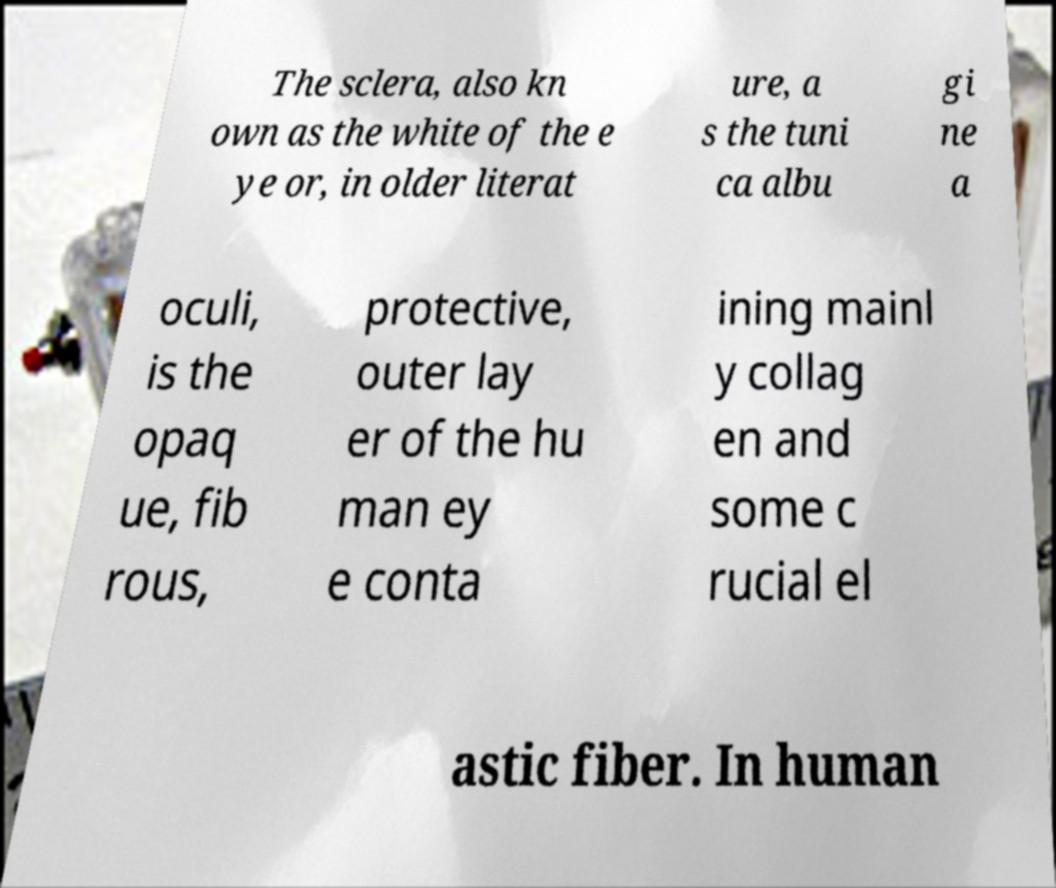Please identify and transcribe the text found in this image. The sclera, also kn own as the white of the e ye or, in older literat ure, a s the tuni ca albu gi ne a oculi, is the opaq ue, fib rous, protective, outer lay er of the hu man ey e conta ining mainl y collag en and some c rucial el astic fiber. In human 